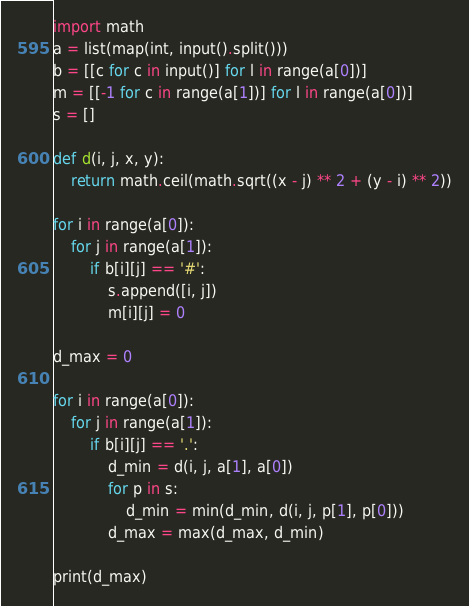<code> <loc_0><loc_0><loc_500><loc_500><_Python_>import math
a = list(map(int, input().split()))
b = [[c for c in input()] for l in range(a[0])]
m = [[-1 for c in range(a[1])] for l in range(a[0])]
s = []

def d(i, j, x, y):
    return math.ceil(math.sqrt((x - j) ** 2 + (y - i) ** 2))

for i in range(a[0]):
    for j in range(a[1]):
        if b[i][j] == '#':
            s.append([i, j])
            m[i][j] = 0

d_max = 0

for i in range(a[0]):
    for j in range(a[1]):
        if b[i][j] == '.':
            d_min = d(i, j, a[1], a[0])
            for p in s:
                d_min = min(d_min, d(i, j, p[1], p[0]))
            d_max = max(d_max, d_min)

print(d_max)
</code> 